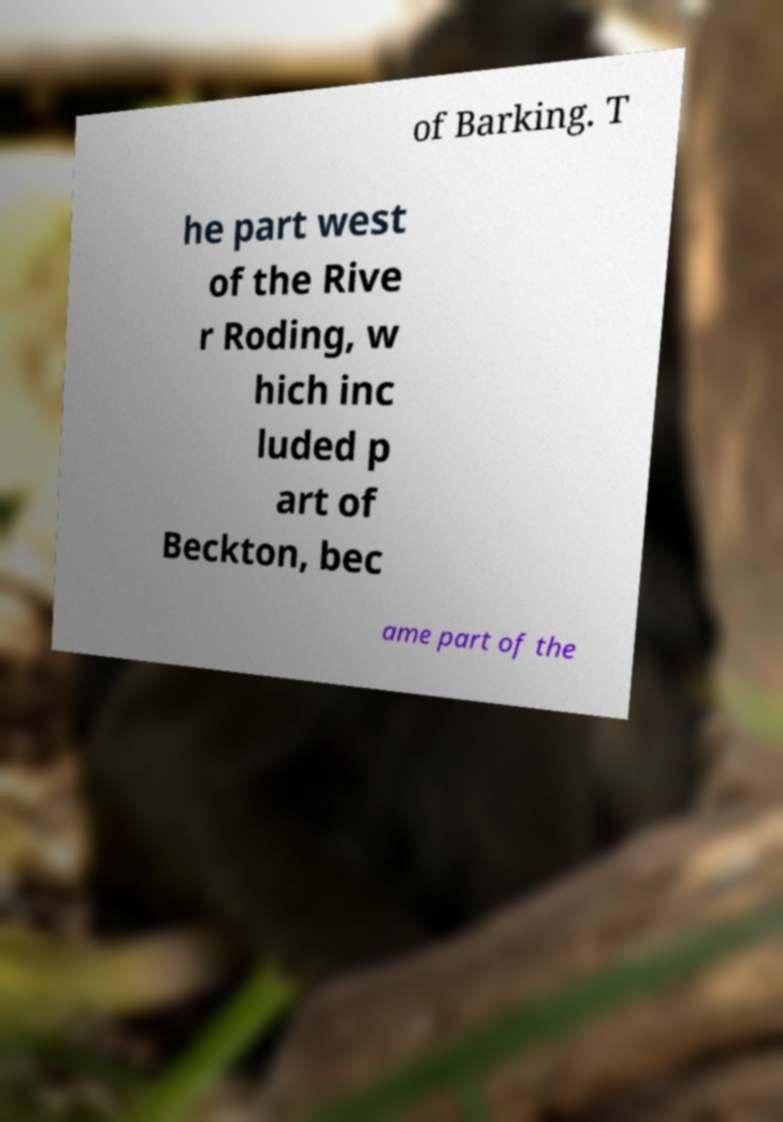Please read and relay the text visible in this image. What does it say? of Barking. T he part west of the Rive r Roding, w hich inc luded p art of Beckton, bec ame part of the 